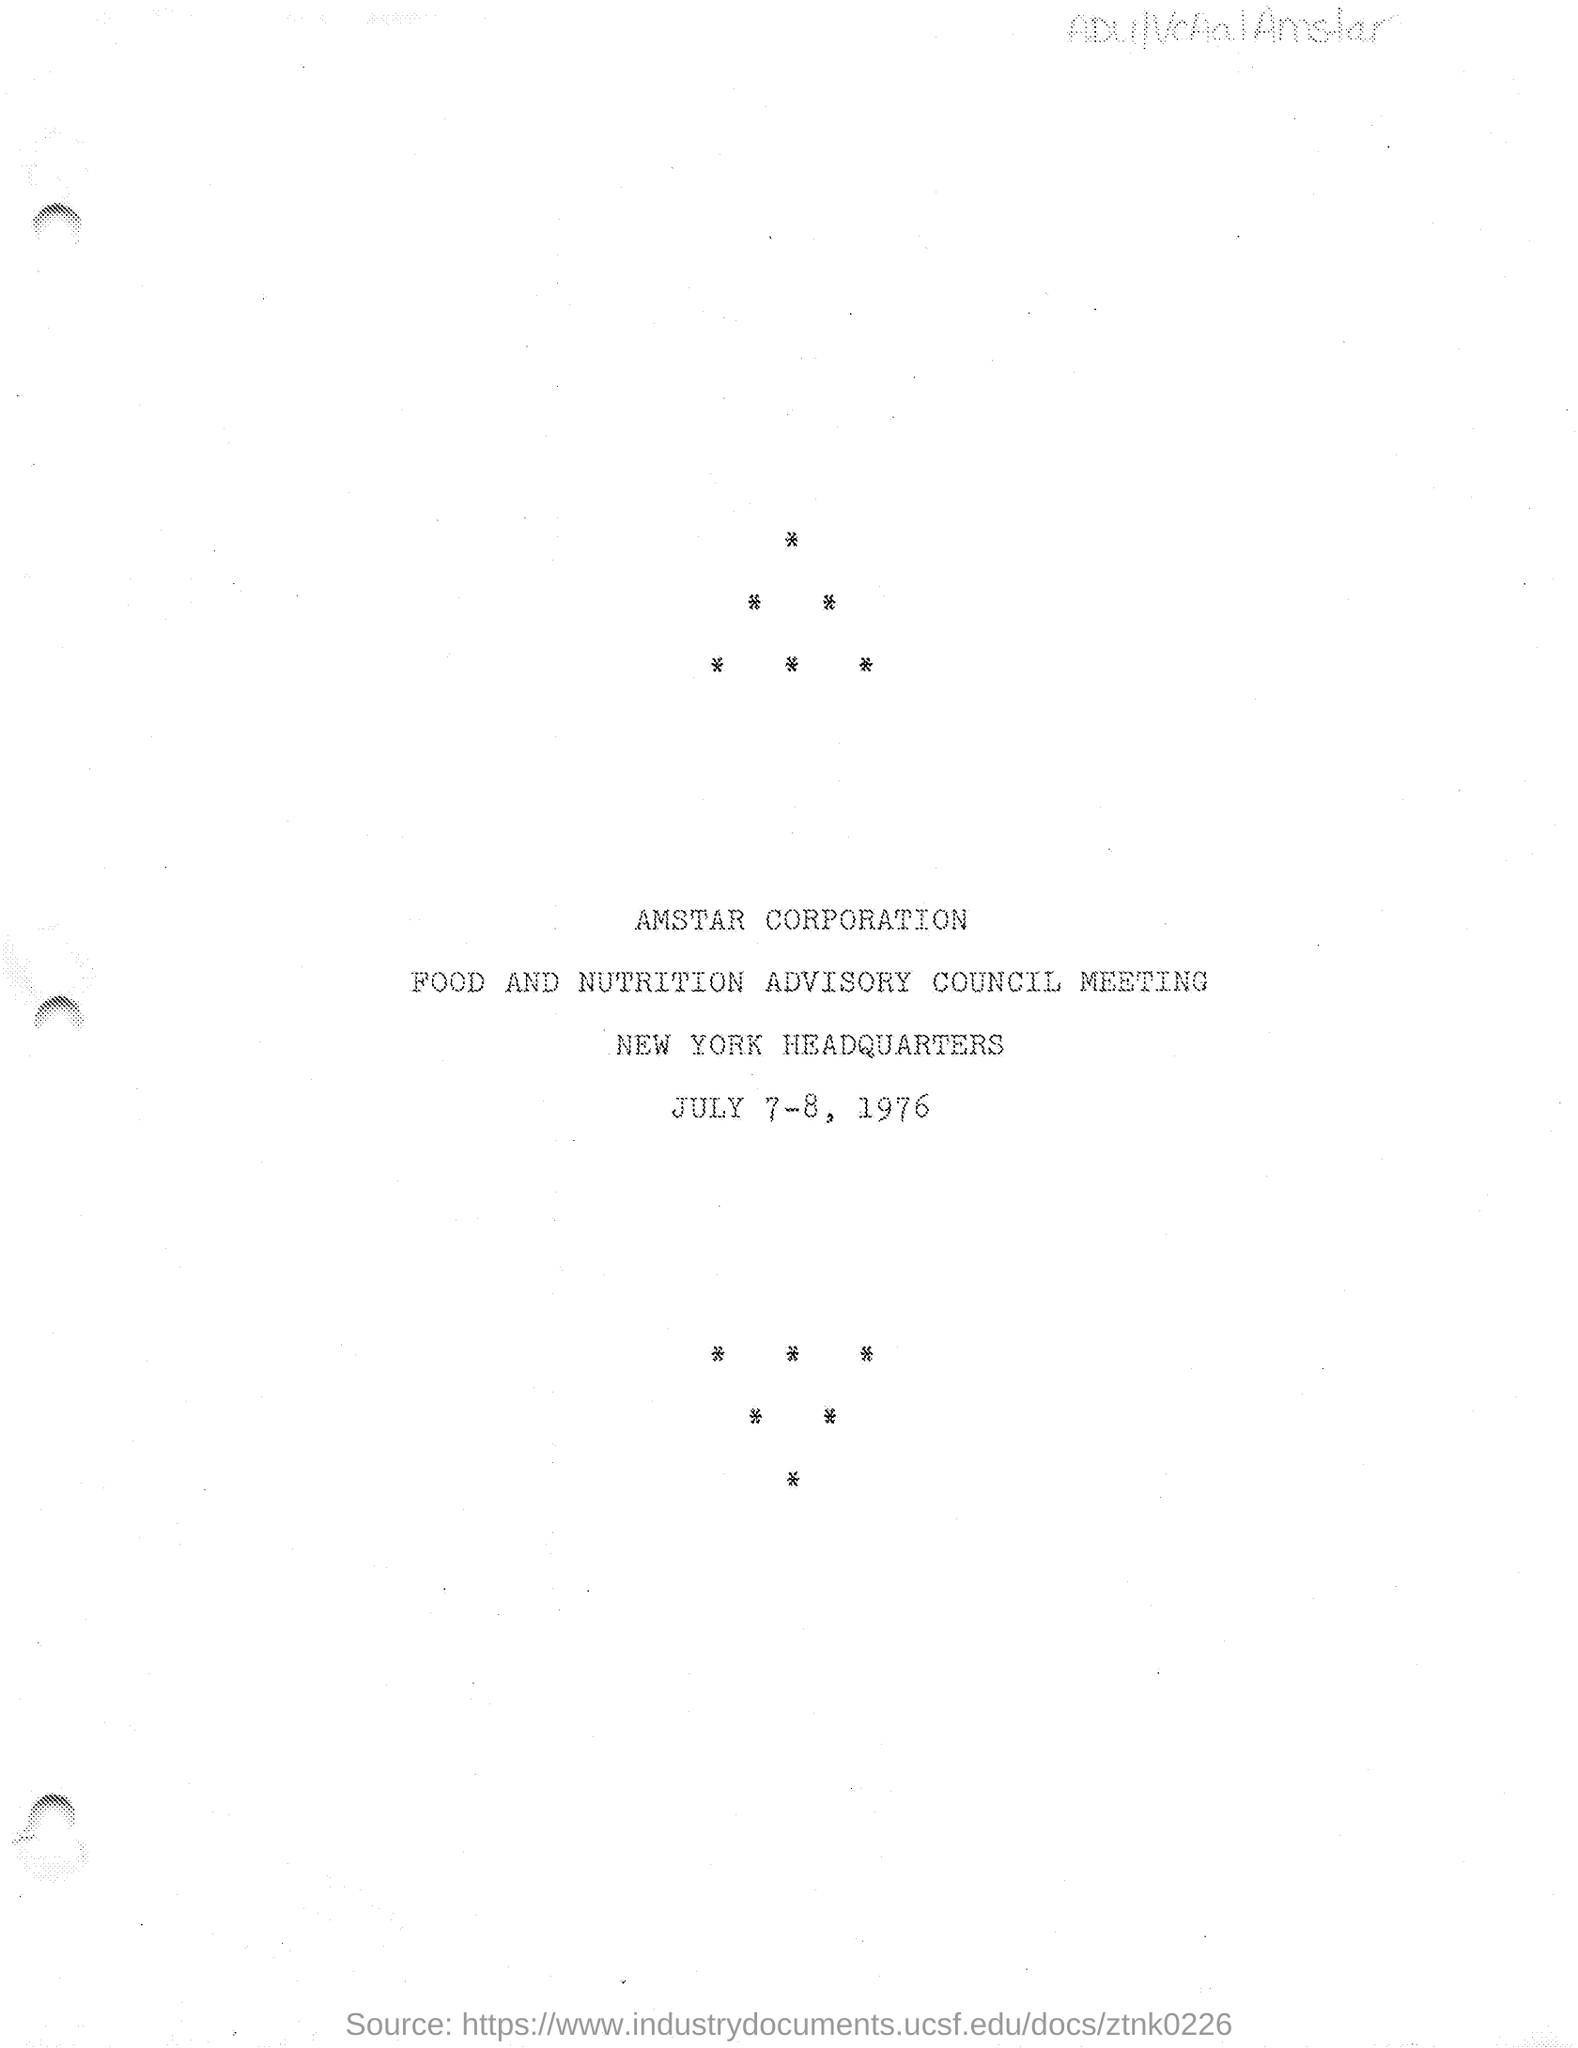Give some essential details in this illustration. The Amstar Corporation is mentioned in the given page. The dates for the meeting are July 7-8, 1976, as mentioned on the given page. The name of the meeting is the Food and Nutrition Advisory Council meeting. The location of the headquarters is New York, as stated on the given page. 